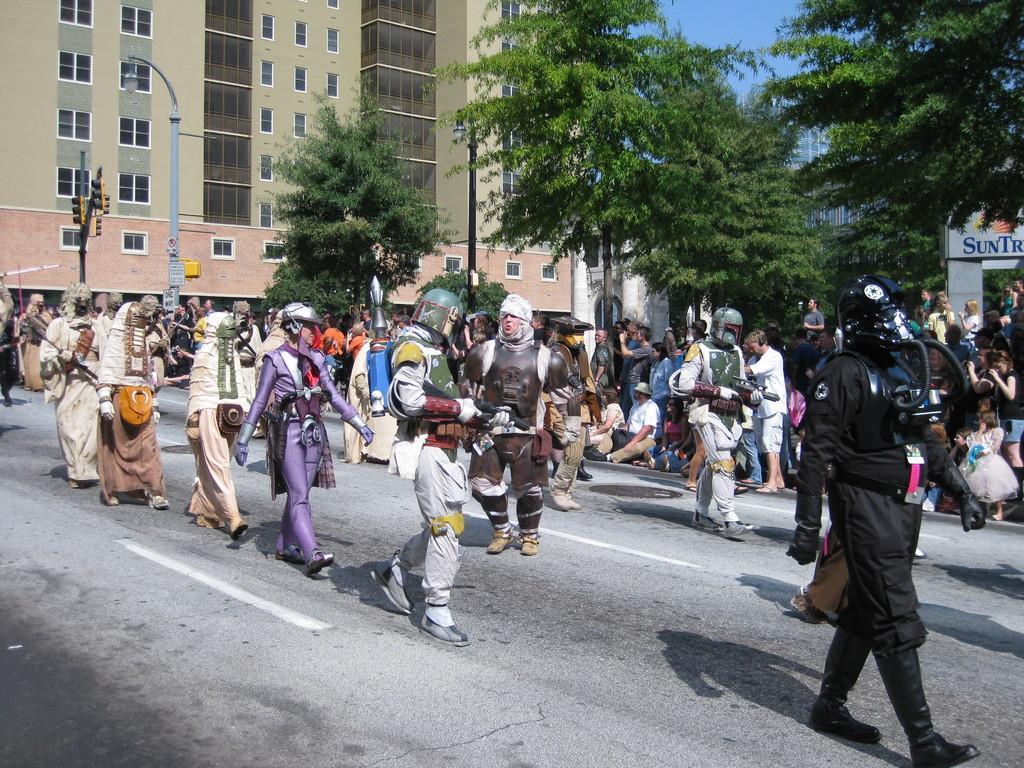Can you describe this image briefly? Front of the image we can see people, signal lights, light poles, boards, trees and hoarding. Among them few people are holding objects. In the background there is a building and sky. 